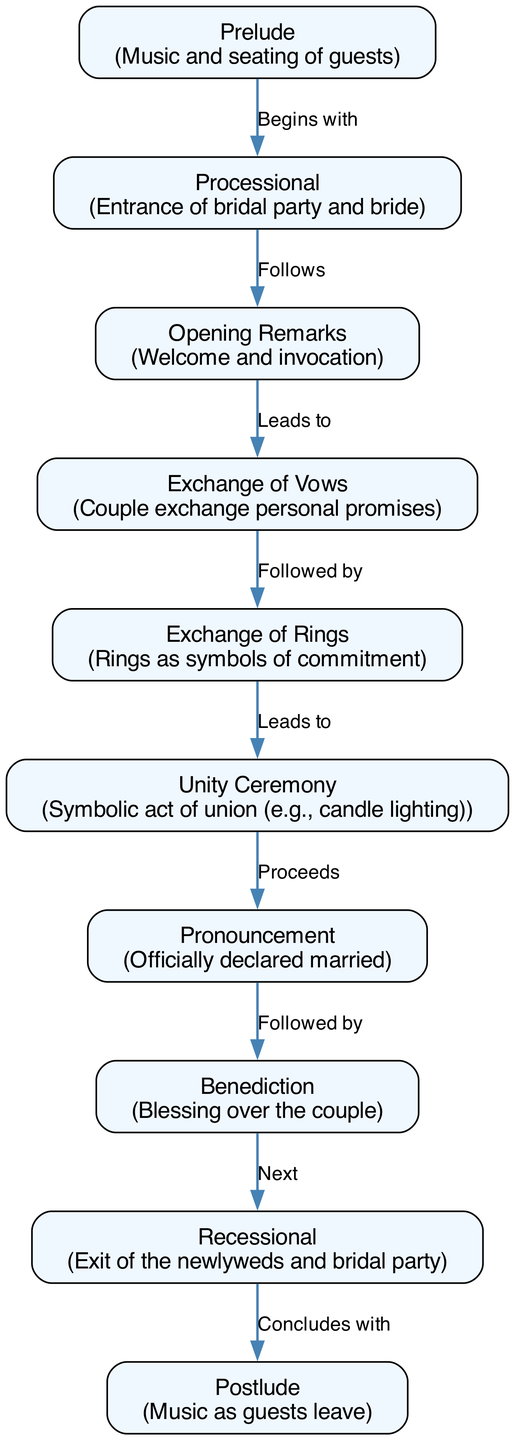What is the first stage of the traditional wedding ceremony? The first stage listed in the diagram is "Prelude," which involves music and the seating of guests. This is the starting point of the ceremony.
Answer: Prelude How many stages are there in the traditional wedding ceremony according to the diagram? By counting each node in the diagram, we find that there are ten distinct stages in the ceremony. Each node corresponds to a specific stage.
Answer: 10 What happens after the "Exchange of Vows"? Following the "Exchange of Vows," the next stage indicated in the diagram is the "Exchange of Rings." This shows the flow of the ceremony from one significant moment to the next.
Answer: Exchange of Rings Which stage directly precedes the "Pronouncement" stage? The "Unity Ceremony" comes directly before the "Pronouncement" in the sequence of events laid out in the diagram, indicating that the unity act occurs just prior to the official declaration of marriage.
Answer: Unity Ceremony What is the final part of the traditional wedding ceremony? The last stage of the ceremony, as represented in the diagram, is the "Postlude," which involves music as guests leave the venue. This signifies the conclusion of the event.
Answer: Postlude What symbolizes commitment during the ceremony? The "Exchange of Rings" is the stage in which rings are exchanged, serving as symbols of the couple's commitment to each other. This is a key component of the ceremony.
Answer: Exchange of Rings What stage leads to the "Benediction"? The stage that precedes the "Benediction" is the "Pronouncement." Upon the official declaration of marriage, the blessing over the couple follows, as shown in the diagram.
Answer: Pronouncement What sequence does the "Processional" follow? The "Processional" stage comes after the "Prelude." This indicates that once guests are seated, the entrance of the bridal party and bride takes place.
Answer: Opening Remarks 